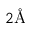Convert formula to latex. <formula><loc_0><loc_0><loc_500><loc_500>2 \AA</formula> 